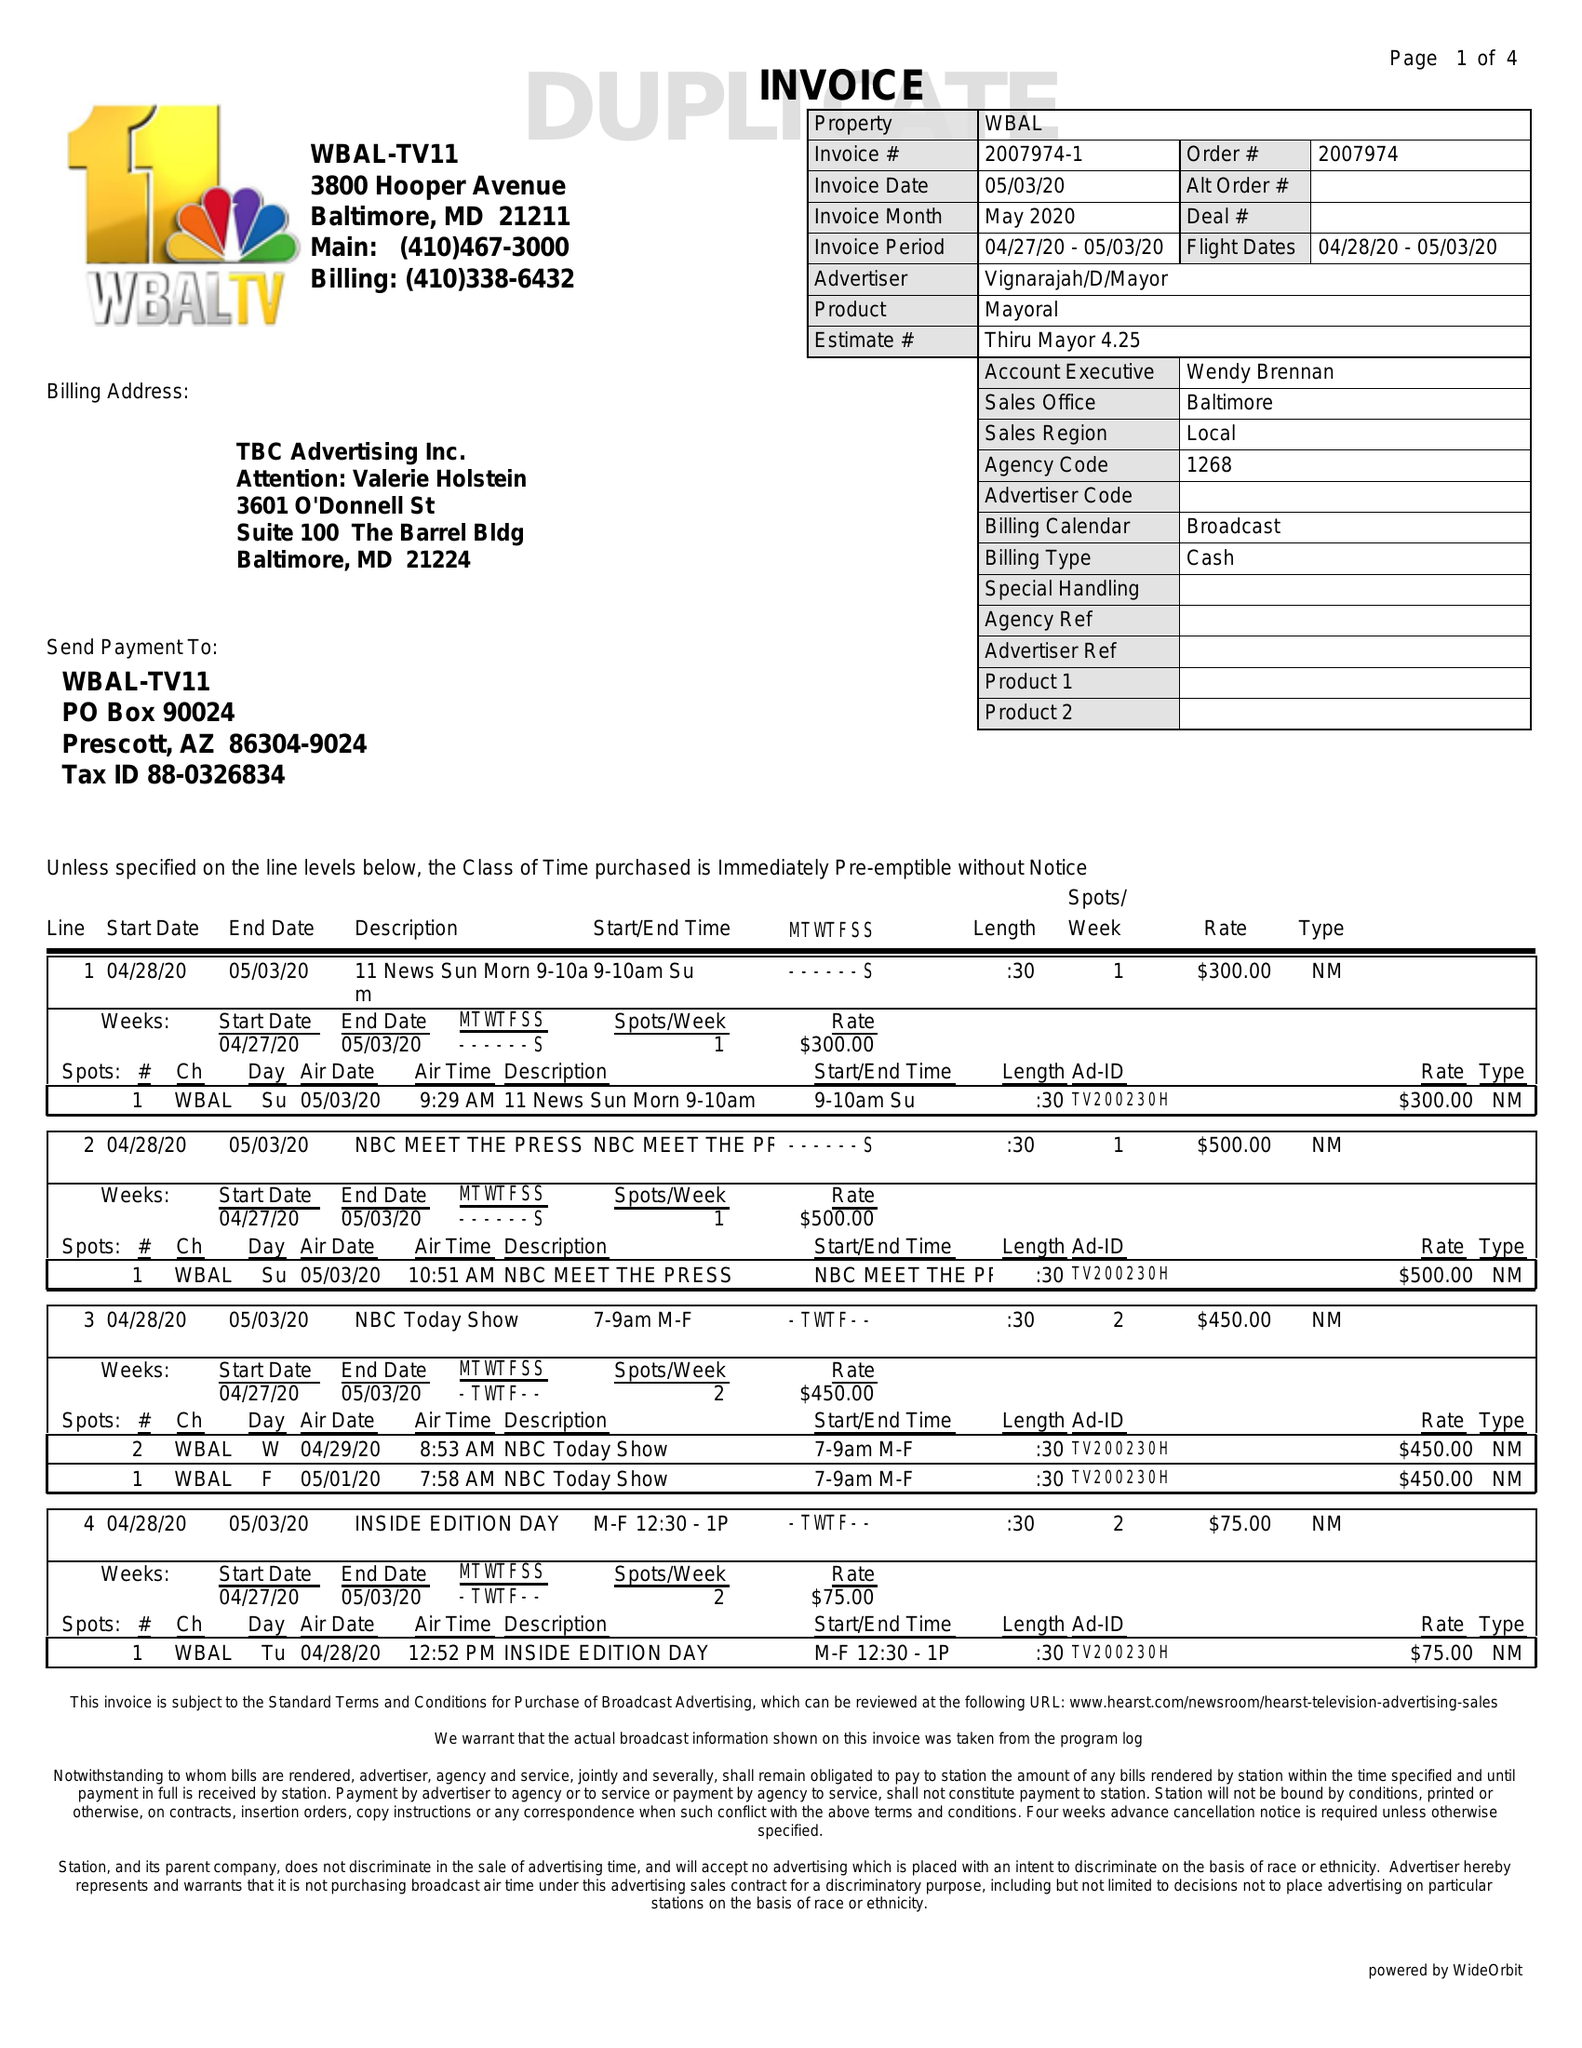What is the value for the flight_to?
Answer the question using a single word or phrase. 05/03/20 